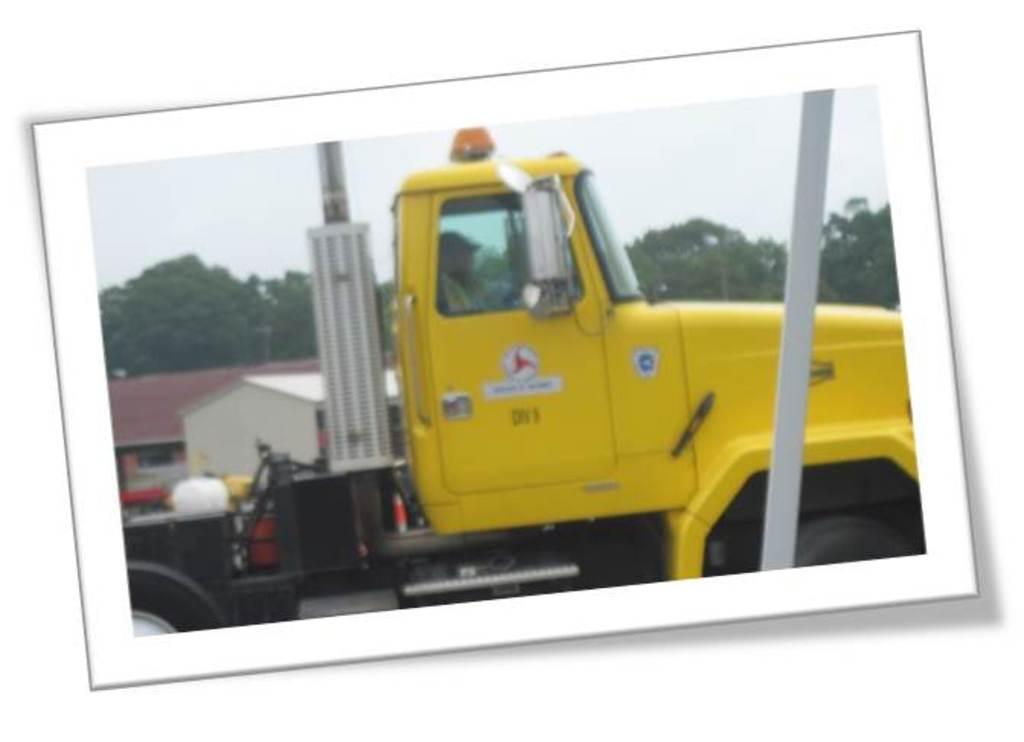Please provide a concise description of this image. In this image there is a photograph, there is the sky, there are trees, there are buildings, there is a vehicle, there is a man sitting inside the vehicle, there is a wooden object, the background of the image is white in color. 